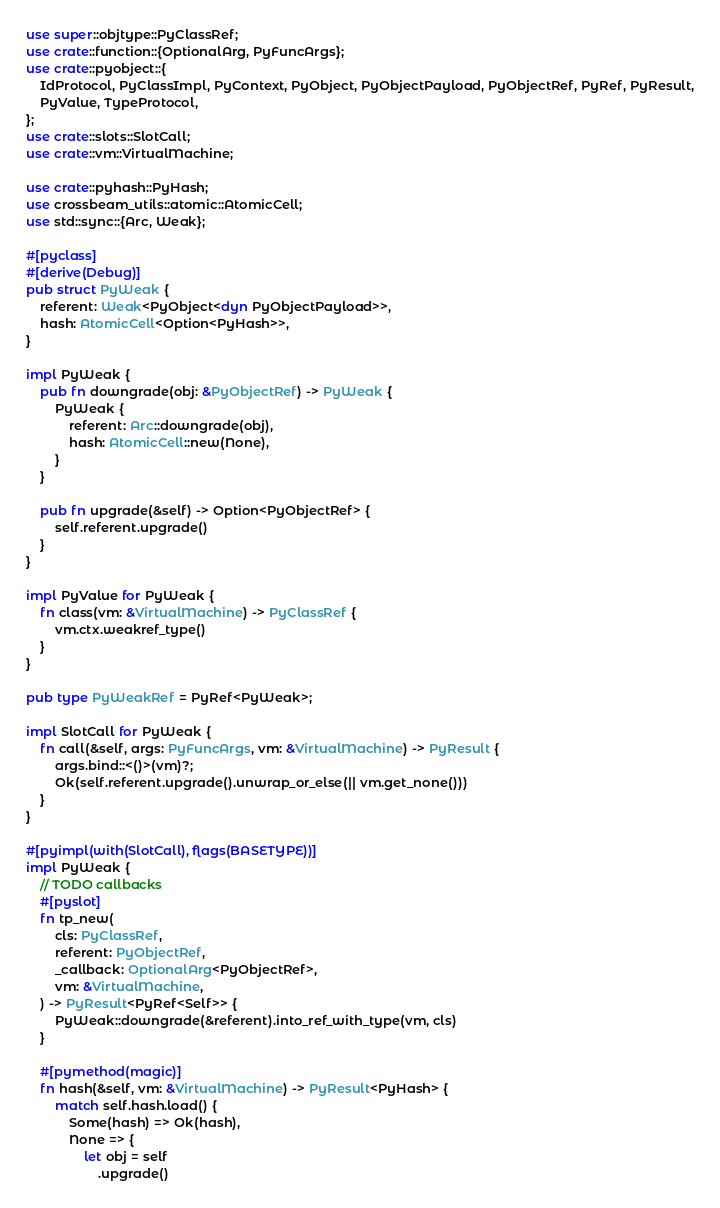<code> <loc_0><loc_0><loc_500><loc_500><_Rust_>use super::objtype::PyClassRef;
use crate::function::{OptionalArg, PyFuncArgs};
use crate::pyobject::{
    IdProtocol, PyClassImpl, PyContext, PyObject, PyObjectPayload, PyObjectRef, PyRef, PyResult,
    PyValue, TypeProtocol,
};
use crate::slots::SlotCall;
use crate::vm::VirtualMachine;

use crate::pyhash::PyHash;
use crossbeam_utils::atomic::AtomicCell;
use std::sync::{Arc, Weak};

#[pyclass]
#[derive(Debug)]
pub struct PyWeak {
    referent: Weak<PyObject<dyn PyObjectPayload>>,
    hash: AtomicCell<Option<PyHash>>,
}

impl PyWeak {
    pub fn downgrade(obj: &PyObjectRef) -> PyWeak {
        PyWeak {
            referent: Arc::downgrade(obj),
            hash: AtomicCell::new(None),
        }
    }

    pub fn upgrade(&self) -> Option<PyObjectRef> {
        self.referent.upgrade()
    }
}

impl PyValue for PyWeak {
    fn class(vm: &VirtualMachine) -> PyClassRef {
        vm.ctx.weakref_type()
    }
}

pub type PyWeakRef = PyRef<PyWeak>;

impl SlotCall for PyWeak {
    fn call(&self, args: PyFuncArgs, vm: &VirtualMachine) -> PyResult {
        args.bind::<()>(vm)?;
        Ok(self.referent.upgrade().unwrap_or_else(|| vm.get_none()))
    }
}

#[pyimpl(with(SlotCall), flags(BASETYPE))]
impl PyWeak {
    // TODO callbacks
    #[pyslot]
    fn tp_new(
        cls: PyClassRef,
        referent: PyObjectRef,
        _callback: OptionalArg<PyObjectRef>,
        vm: &VirtualMachine,
    ) -> PyResult<PyRef<Self>> {
        PyWeak::downgrade(&referent).into_ref_with_type(vm, cls)
    }

    #[pymethod(magic)]
    fn hash(&self, vm: &VirtualMachine) -> PyResult<PyHash> {
        match self.hash.load() {
            Some(hash) => Ok(hash),
            None => {
                let obj = self
                    .upgrade()</code> 